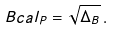<formula> <loc_0><loc_0><loc_500><loc_500>\ B c a l _ { P } = \sqrt { \Delta _ { B } } \, .</formula> 